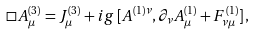Convert formula to latex. <formula><loc_0><loc_0><loc_500><loc_500>\Box A _ { \mu } ^ { ( 3 ) } = J _ { \mu } ^ { ( 3 ) } + i g \, [ A ^ { ( 1 ) \nu } , \partial _ { \nu } A _ { \mu } ^ { ( 1 ) } + F _ { \nu \mu } ^ { ( 1 ) } ] \, ,</formula> 